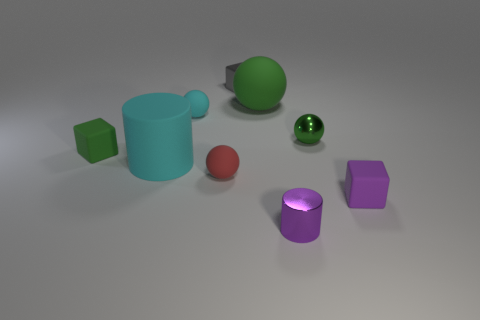There is a red matte ball right of the cyan sphere; is there a metallic sphere that is behind it?
Your answer should be very brief. Yes. There is a cyan sphere; are there any green blocks in front of it?
Provide a succinct answer. Yes. There is a big thing that is on the left side of the tiny metallic block; is it the same shape as the tiny gray shiny thing?
Offer a very short reply. No. What number of other tiny gray things have the same shape as the tiny gray metallic object?
Provide a short and direct response. 0. Is there a gray thing that has the same material as the small purple cylinder?
Offer a very short reply. Yes. What material is the large thing that is behind the small matte cube to the left of the small green metal sphere made of?
Offer a terse response. Rubber. There is a green matte object behind the small cyan rubber sphere; what is its size?
Give a very brief answer. Large. There is a large ball; is it the same color as the tiny matte block that is behind the purple block?
Provide a short and direct response. Yes. Are there any tiny matte cubes that have the same color as the tiny metallic sphere?
Your response must be concise. Yes. Are the tiny green ball and the cylinder left of the tiny gray cube made of the same material?
Keep it short and to the point. No. 